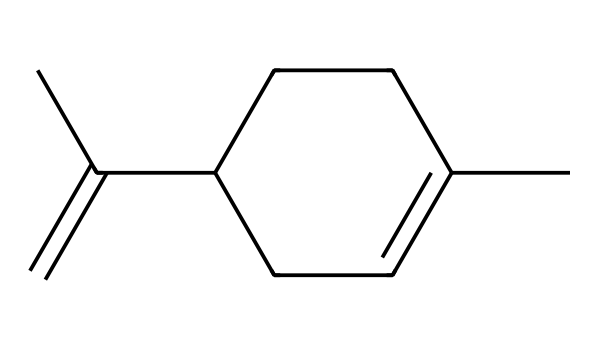What is the molecular formula of limonene? The SMILES notation indicates that limonene consists of 10 carbon (C) atoms and 16 hydrogen (H) atoms. Counting from the structure represented in the SMILES, we derive the molecular formula C10H16.
Answer: C10H16 How many rings are present in the structure of limonene? By analyzing the SMILES string, we can identify that there is only one ring present, as denoted by ‘C1’ and 'CC1' in the SMILES representation. This indicates a cycloalkane part of the structure.
Answer: 1 What functional group is associated with limonene? While the predominant nature of limonene is hydrocarbon, it specifically has a double bond in the ring, suggesting it is an alkene. This is inferred from the part of the structure that features C=C (the double bond).
Answer: alkene Is limonene saturated or unsaturated? The presence of a double bond (C=C) in the structure indicates that limonene is an unsaturated hydrocarbon, as saturated hydrocarbons would not contain double bonds.
Answer: unsaturated What type of hydrocarbon is limonene categorized as? Given that limonene has a ring structure and contains double bonds, it is classified as a cyclic alkene, which is a specific type of hydrocarbon distinguished by these characteristics.
Answer: cyclic alkene How many carbon atoms are connected to the double bond in limonene? In the structure of limonene, two carbon atoms are directly involved in the double bond (C=C), indicating a direct connection between those two specific carbons.
Answer: 2 What geometric arrangement is suggested by the double bond in limonene? The presence of a double bond (C=C) in limonene suggests a planar arrangement around the double bond due to the sp² hybridization of the involved carbon atoms, which limits rotation and maintains a fixed orientation.
Answer: planar 